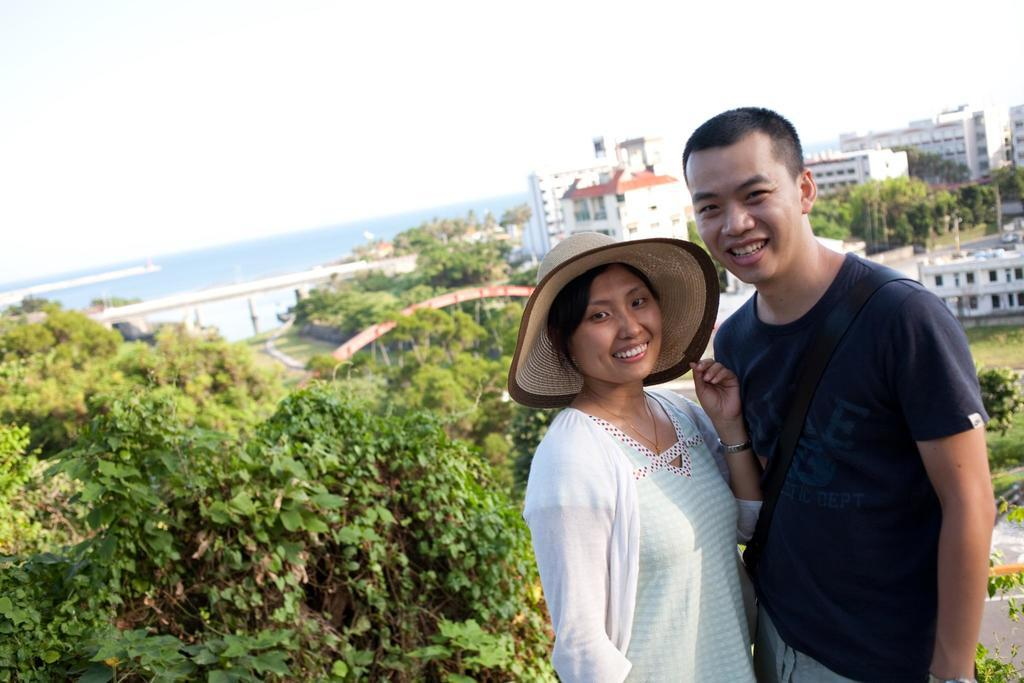What type of structures can be seen in the image? There are buildings in the image. What other natural elements are present in the image? There are trees and water visible in the image. Who is present in the image? There is a man and a woman in the image. What is the emotional expression of the man and woman? The man and woman are smiling in the image. What is the woman wearing on her head? The woman is wearing a cap in the image. How would you describe the weather based on the sky? The sky is cloudy in the image. What type of jewel is the man wearing around his neck in the image? There is no mention of a jewel or any accessory around the man's neck in the image. What song is the woman singing in the image? There is no indication that the woman is singing in the image. 